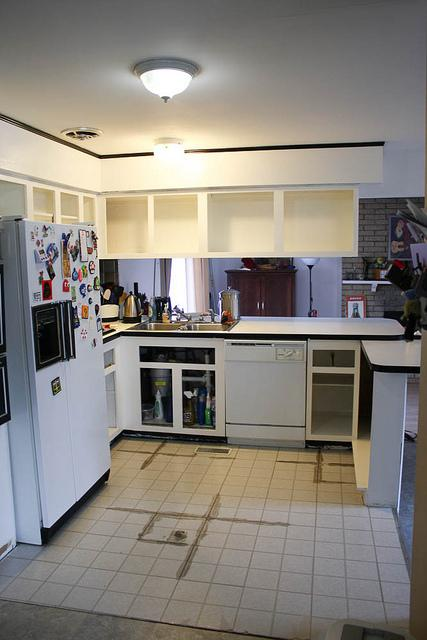What room is beyond the countertops? Please explain your reasoning. living room. The countertops are in the kitchen. the kitchen separates the kitchen and living room. 